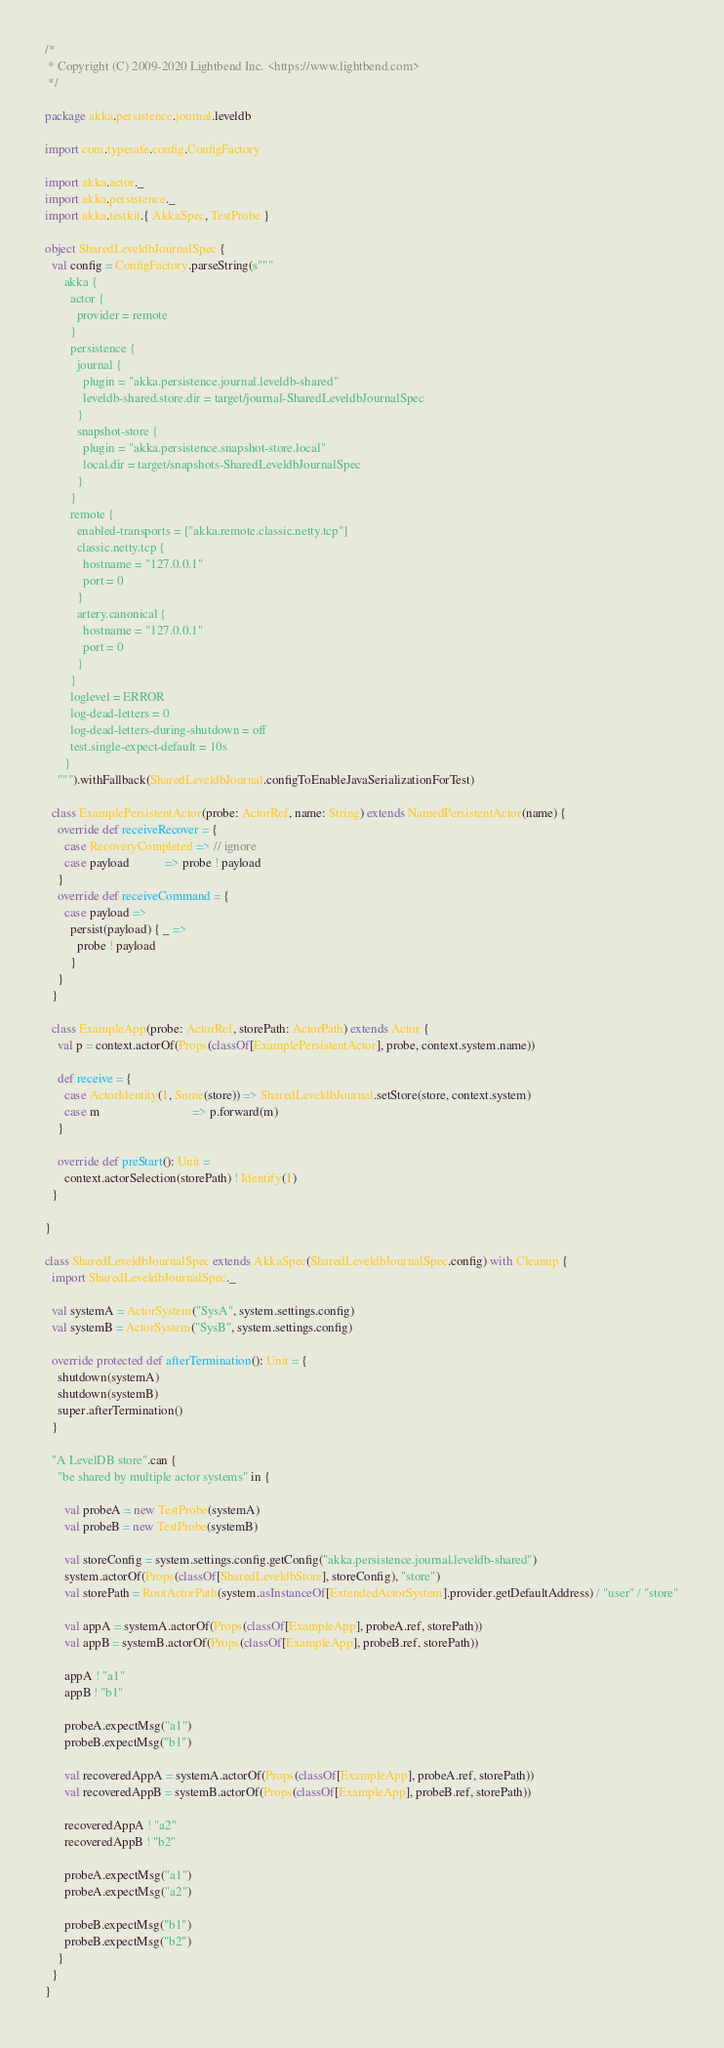Convert code to text. <code><loc_0><loc_0><loc_500><loc_500><_Scala_>/*
 * Copyright (C) 2009-2020 Lightbend Inc. <https://www.lightbend.com>
 */

package akka.persistence.journal.leveldb

import com.typesafe.config.ConfigFactory

import akka.actor._
import akka.persistence._
import akka.testkit.{ AkkaSpec, TestProbe }

object SharedLeveldbJournalSpec {
  val config = ConfigFactory.parseString(s"""
      akka {
        actor {
          provider = remote
        }
        persistence {
          journal {
            plugin = "akka.persistence.journal.leveldb-shared"
            leveldb-shared.store.dir = target/journal-SharedLeveldbJournalSpec
          }
          snapshot-store {
            plugin = "akka.persistence.snapshot-store.local"
            local.dir = target/snapshots-SharedLeveldbJournalSpec
          }
        }
        remote {
          enabled-transports = ["akka.remote.classic.netty.tcp"]
          classic.netty.tcp {
            hostname = "127.0.0.1"
            port = 0
          }
          artery.canonical {
            hostname = "127.0.0.1"
            port = 0
          }
        }
        loglevel = ERROR
        log-dead-letters = 0
        log-dead-letters-during-shutdown = off
        test.single-expect-default = 10s
      }
    """).withFallback(SharedLeveldbJournal.configToEnableJavaSerializationForTest)

  class ExamplePersistentActor(probe: ActorRef, name: String) extends NamedPersistentActor(name) {
    override def receiveRecover = {
      case RecoveryCompleted => // ignore
      case payload           => probe ! payload
    }
    override def receiveCommand = {
      case payload =>
        persist(payload) { _ =>
          probe ! payload
        }
    }
  }

  class ExampleApp(probe: ActorRef, storePath: ActorPath) extends Actor {
    val p = context.actorOf(Props(classOf[ExamplePersistentActor], probe, context.system.name))

    def receive = {
      case ActorIdentity(1, Some(store)) => SharedLeveldbJournal.setStore(store, context.system)
      case m                             => p.forward(m)
    }

    override def preStart(): Unit =
      context.actorSelection(storePath) ! Identify(1)
  }

}

class SharedLeveldbJournalSpec extends AkkaSpec(SharedLeveldbJournalSpec.config) with Cleanup {
  import SharedLeveldbJournalSpec._

  val systemA = ActorSystem("SysA", system.settings.config)
  val systemB = ActorSystem("SysB", system.settings.config)

  override protected def afterTermination(): Unit = {
    shutdown(systemA)
    shutdown(systemB)
    super.afterTermination()
  }

  "A LevelDB store".can {
    "be shared by multiple actor systems" in {

      val probeA = new TestProbe(systemA)
      val probeB = new TestProbe(systemB)

      val storeConfig = system.settings.config.getConfig("akka.persistence.journal.leveldb-shared")
      system.actorOf(Props(classOf[SharedLeveldbStore], storeConfig), "store")
      val storePath = RootActorPath(system.asInstanceOf[ExtendedActorSystem].provider.getDefaultAddress) / "user" / "store"

      val appA = systemA.actorOf(Props(classOf[ExampleApp], probeA.ref, storePath))
      val appB = systemB.actorOf(Props(classOf[ExampleApp], probeB.ref, storePath))

      appA ! "a1"
      appB ! "b1"

      probeA.expectMsg("a1")
      probeB.expectMsg("b1")

      val recoveredAppA = systemA.actorOf(Props(classOf[ExampleApp], probeA.ref, storePath))
      val recoveredAppB = systemB.actorOf(Props(classOf[ExampleApp], probeB.ref, storePath))

      recoveredAppA ! "a2"
      recoveredAppB ! "b2"

      probeA.expectMsg("a1")
      probeA.expectMsg("a2")

      probeB.expectMsg("b1")
      probeB.expectMsg("b2")
    }
  }
}
</code> 